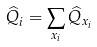<formula> <loc_0><loc_0><loc_500><loc_500>\widehat { Q } _ { i } = \sum _ { x _ { i } } \widehat { Q } _ { x _ { i } }</formula> 